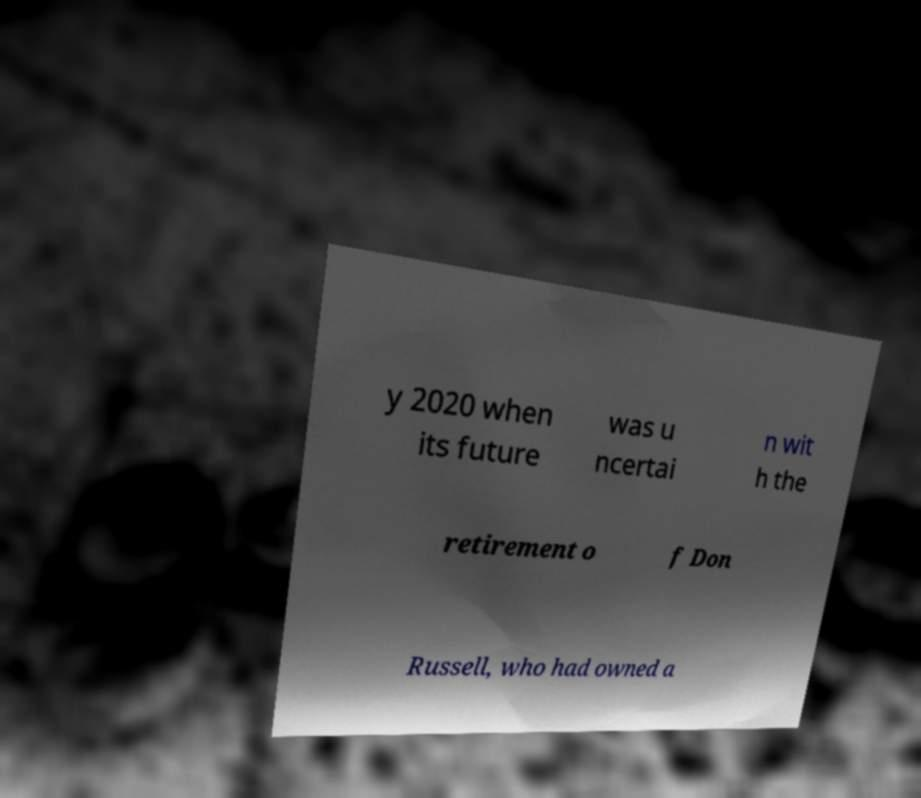Could you extract and type out the text from this image? y 2020 when its future was u ncertai n wit h the retirement o f Don Russell, who had owned a 